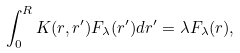<formula> <loc_0><loc_0><loc_500><loc_500>\int _ { 0 } ^ { R } K ( r , r ^ { \prime } ) F _ { \lambda } ( r ^ { \prime } ) d r ^ { \prime } = \lambda F _ { \lambda } ( r ) ,</formula> 